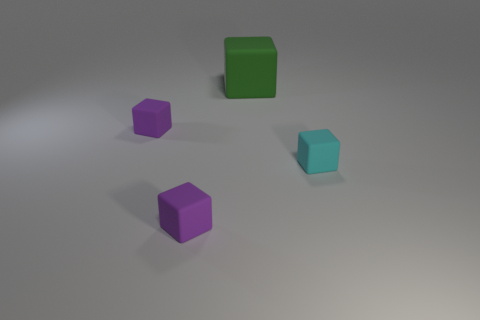Add 3 cylinders. How many objects exist? 7 Subtract 0 yellow balls. How many objects are left? 4 Subtract all large green rubber cubes. Subtract all small purple rubber cubes. How many objects are left? 1 Add 2 tiny rubber blocks. How many tiny rubber blocks are left? 5 Add 4 green things. How many green things exist? 5 